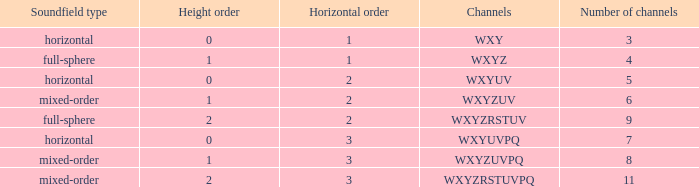If the height order is 1 and the soundfield type is mixed-order, what are all the channels? WXYZUV, WXYZUVPQ. 